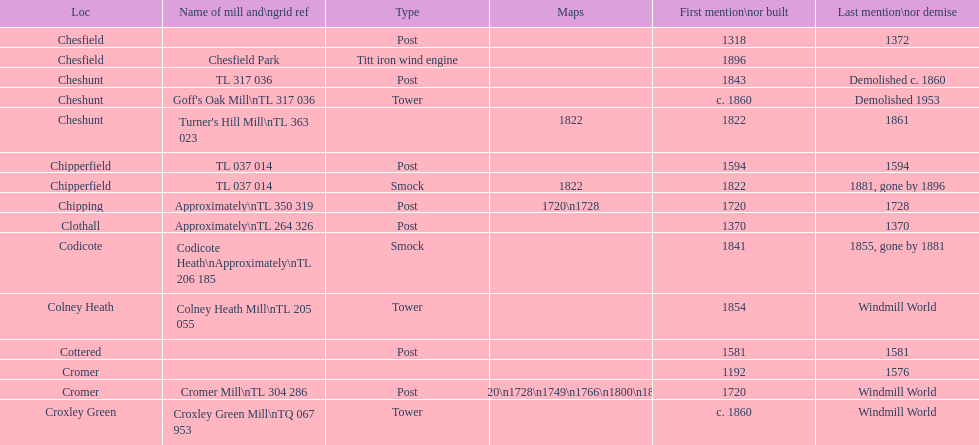What is the total of mills first cited or established in the 1800s? 8. 